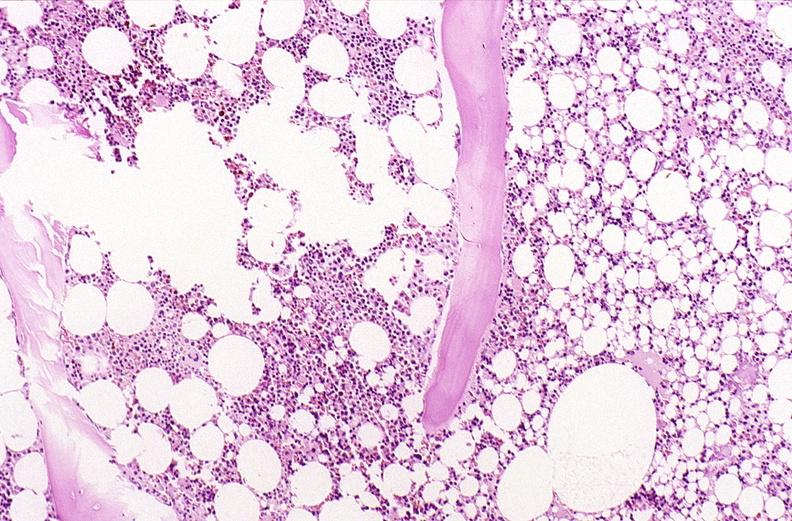does this image show bone, vertebral body opsteopenia, osteoporosis?
Answer the question using a single word or phrase. Yes 